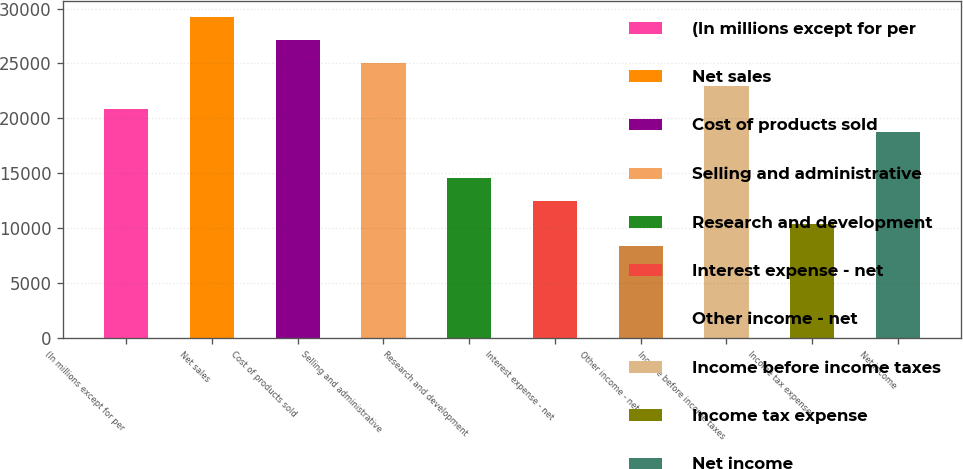Convert chart to OTSL. <chart><loc_0><loc_0><loc_500><loc_500><bar_chart><fcel>(In millions except for per<fcel>Net sales<fcel>Cost of products sold<fcel>Selling and administrative<fcel>Research and development<fcel>Interest expense - net<fcel>Other income - net<fcel>Income before income taxes<fcel>Income tax expense<fcel>Net income<nl><fcel>20855<fcel>29196.2<fcel>27110.9<fcel>25025.6<fcel>14599.1<fcel>12513.8<fcel>8343.2<fcel>22940.3<fcel>10428.5<fcel>18769.7<nl></chart> 